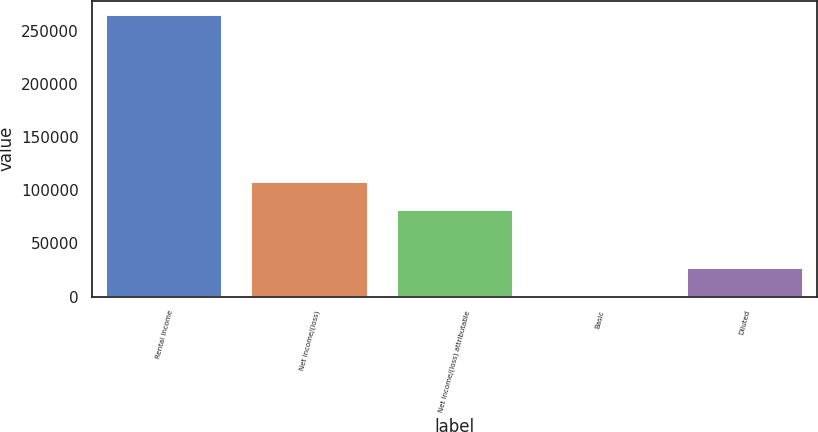Convert chart. <chart><loc_0><loc_0><loc_500><loc_500><bar_chart><fcel>Rental income<fcel>Net income/(loss)<fcel>Net income/(loss) attributable<fcel>Basic<fcel>Diluted<nl><fcel>264732<fcel>107641<fcel>81168<fcel>0.3<fcel>26473.5<nl></chart> 